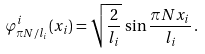<formula> <loc_0><loc_0><loc_500><loc_500>\varphi ^ { i } _ { \pi N / l _ { i } } ( x _ { i } ) = \sqrt { \frac { 2 } { l _ { i } } } \, \sin \frac { \pi N x _ { i } } { l _ { i } } \, .</formula> 